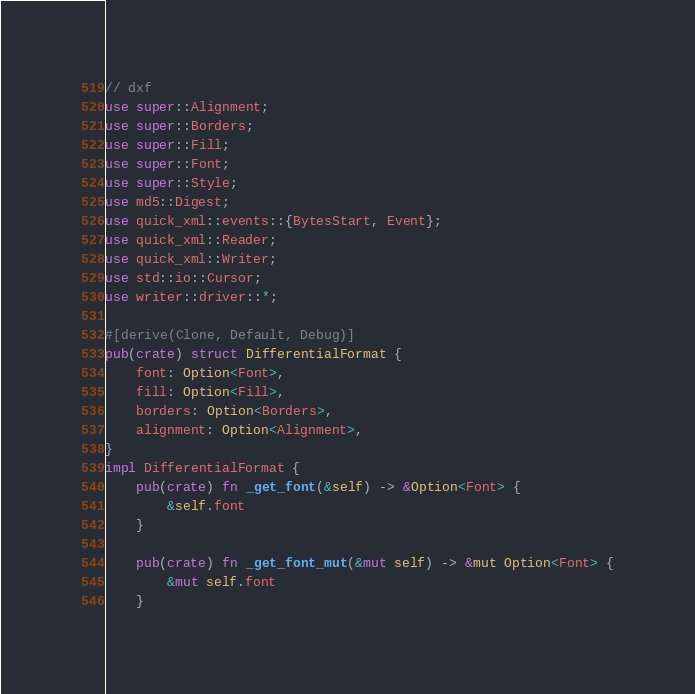Convert code to text. <code><loc_0><loc_0><loc_500><loc_500><_Rust_>// dxf
use super::Alignment;
use super::Borders;
use super::Fill;
use super::Font;
use super::Style;
use md5::Digest;
use quick_xml::events::{BytesStart, Event};
use quick_xml::Reader;
use quick_xml::Writer;
use std::io::Cursor;
use writer::driver::*;

#[derive(Clone, Default, Debug)]
pub(crate) struct DifferentialFormat {
    font: Option<Font>,
    fill: Option<Fill>,
    borders: Option<Borders>,
    alignment: Option<Alignment>,
}
impl DifferentialFormat {
    pub(crate) fn _get_font(&self) -> &Option<Font> {
        &self.font
    }

    pub(crate) fn _get_font_mut(&mut self) -> &mut Option<Font> {
        &mut self.font
    }
</code> 